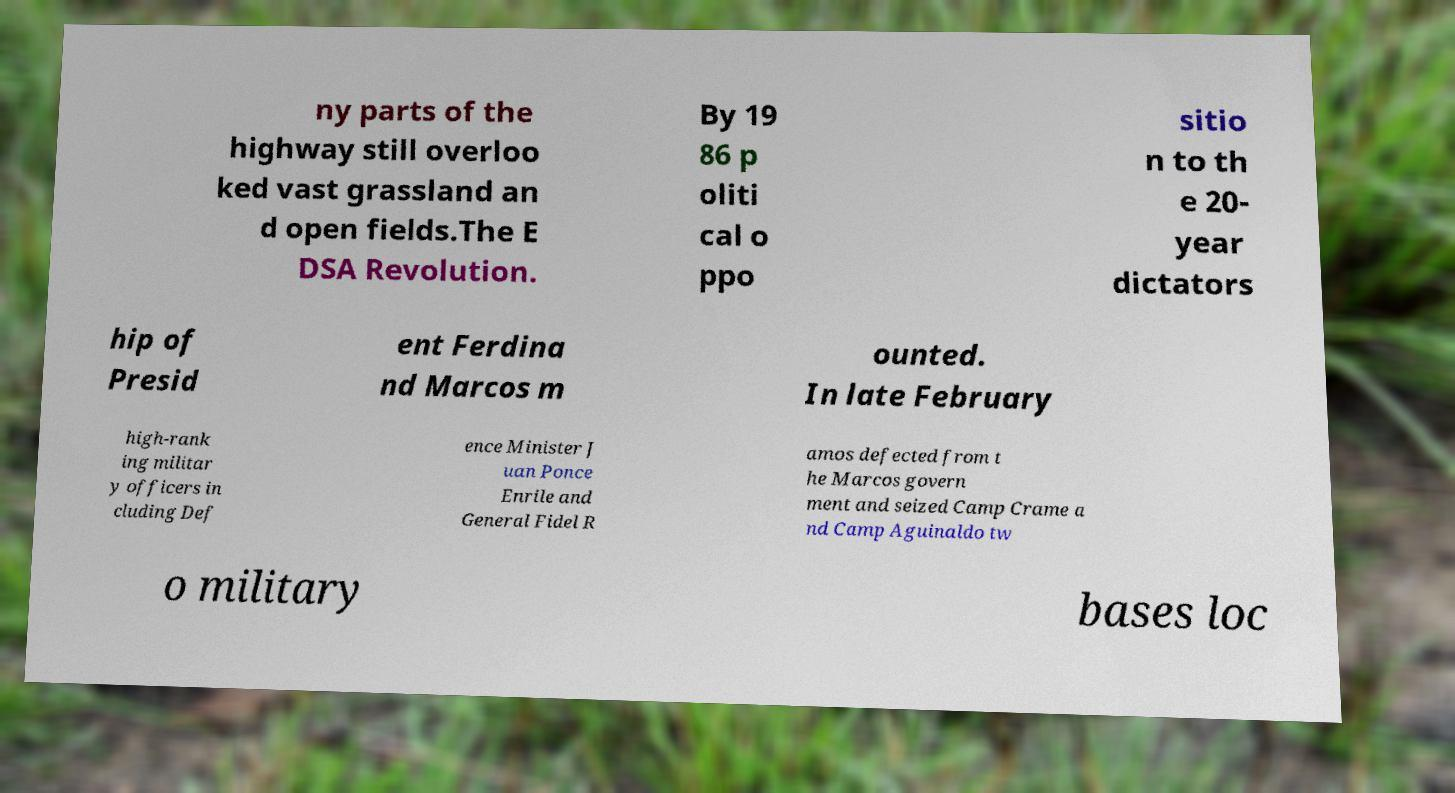Could you extract and type out the text from this image? ny parts of the highway still overloo ked vast grassland an d open fields.The E DSA Revolution. By 19 86 p oliti cal o ppo sitio n to th e 20- year dictators hip of Presid ent Ferdina nd Marcos m ounted. In late February high-rank ing militar y officers in cluding Def ence Minister J uan Ponce Enrile and General Fidel R amos defected from t he Marcos govern ment and seized Camp Crame a nd Camp Aguinaldo tw o military bases loc 